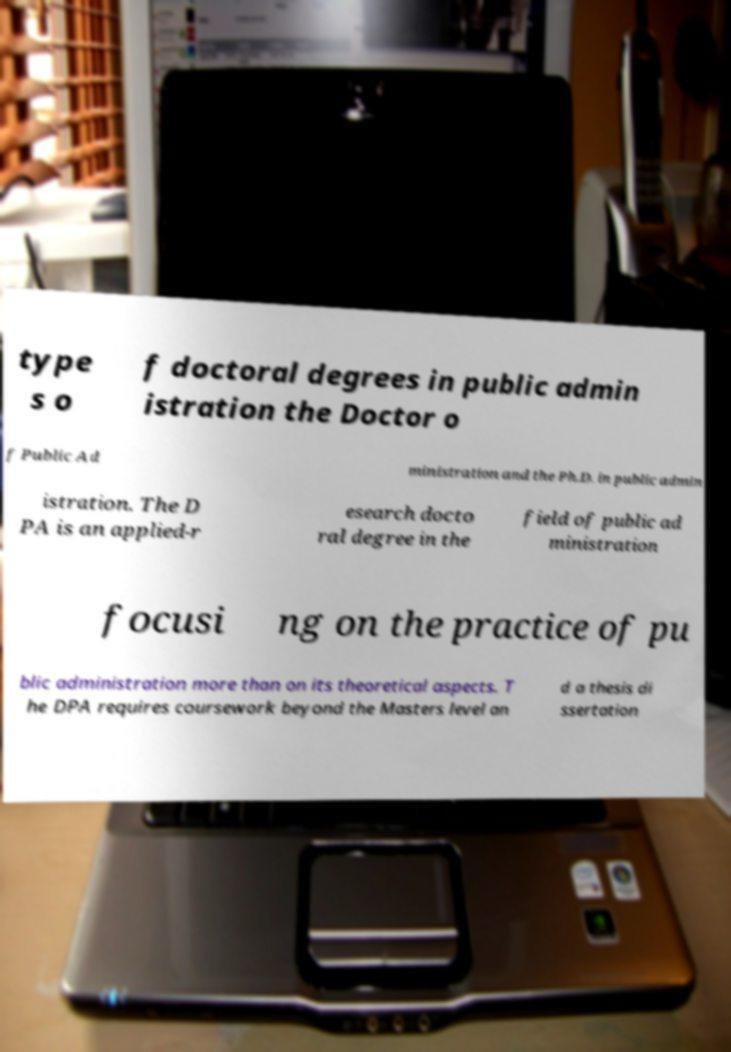For documentation purposes, I need the text within this image transcribed. Could you provide that? type s o f doctoral degrees in public admin istration the Doctor o f Public Ad ministration and the Ph.D. in public admin istration. The D PA is an applied-r esearch docto ral degree in the field of public ad ministration focusi ng on the practice of pu blic administration more than on its theoretical aspects. T he DPA requires coursework beyond the Masters level an d a thesis di ssertation 